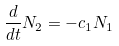<formula> <loc_0><loc_0><loc_500><loc_500>\frac { d } { d t } N _ { 2 } = - c _ { 1 } N _ { 1 }</formula> 